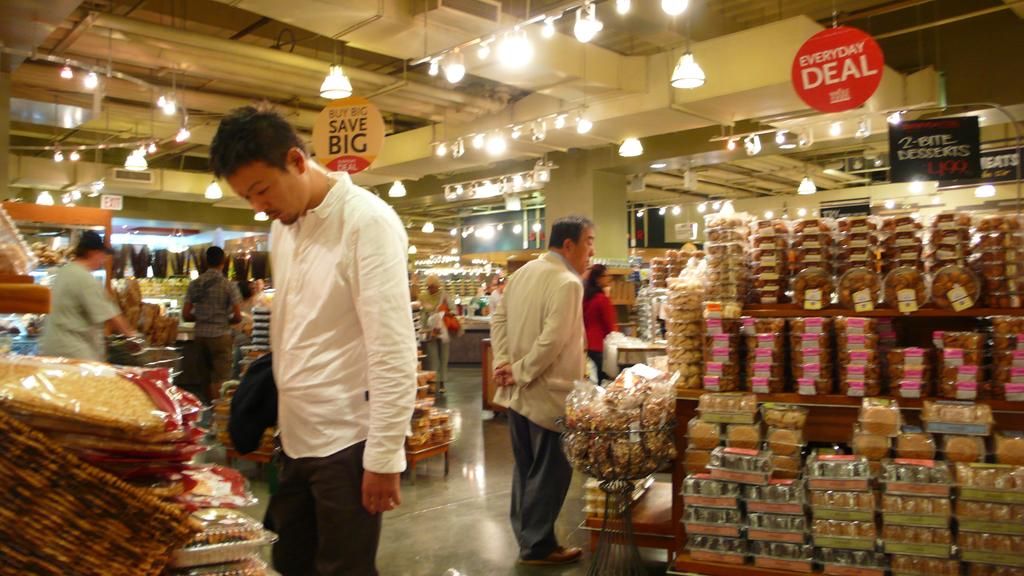When are the deals?
Your answer should be compact. Everyday. What does it say after "buy big"?
Give a very brief answer. Save big. 